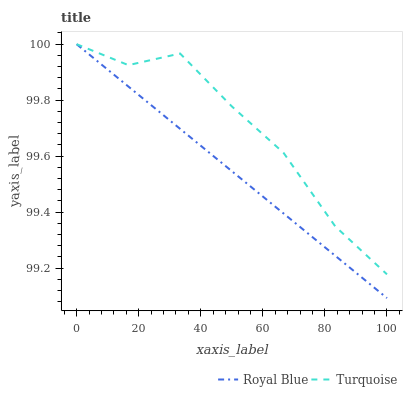Does Royal Blue have the minimum area under the curve?
Answer yes or no. Yes. Does Turquoise have the maximum area under the curve?
Answer yes or no. Yes. Does Turquoise have the minimum area under the curve?
Answer yes or no. No. Is Royal Blue the smoothest?
Answer yes or no. Yes. Is Turquoise the roughest?
Answer yes or no. Yes. Is Turquoise the smoothest?
Answer yes or no. No. Does Turquoise have the lowest value?
Answer yes or no. No. Does Turquoise have the highest value?
Answer yes or no. Yes. 